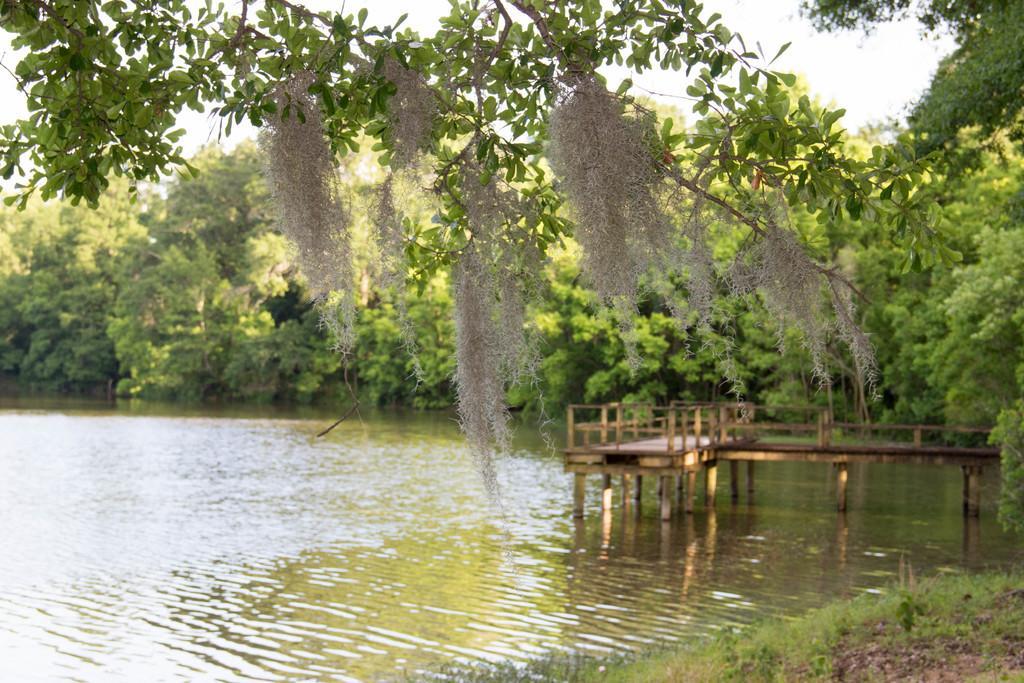Describe this image in one or two sentences. In this image I see number of trees and I see the wooden platform over here and I see the water and I see the white color things on the stems over here and I see the grass over here and I see the sky in the background. 